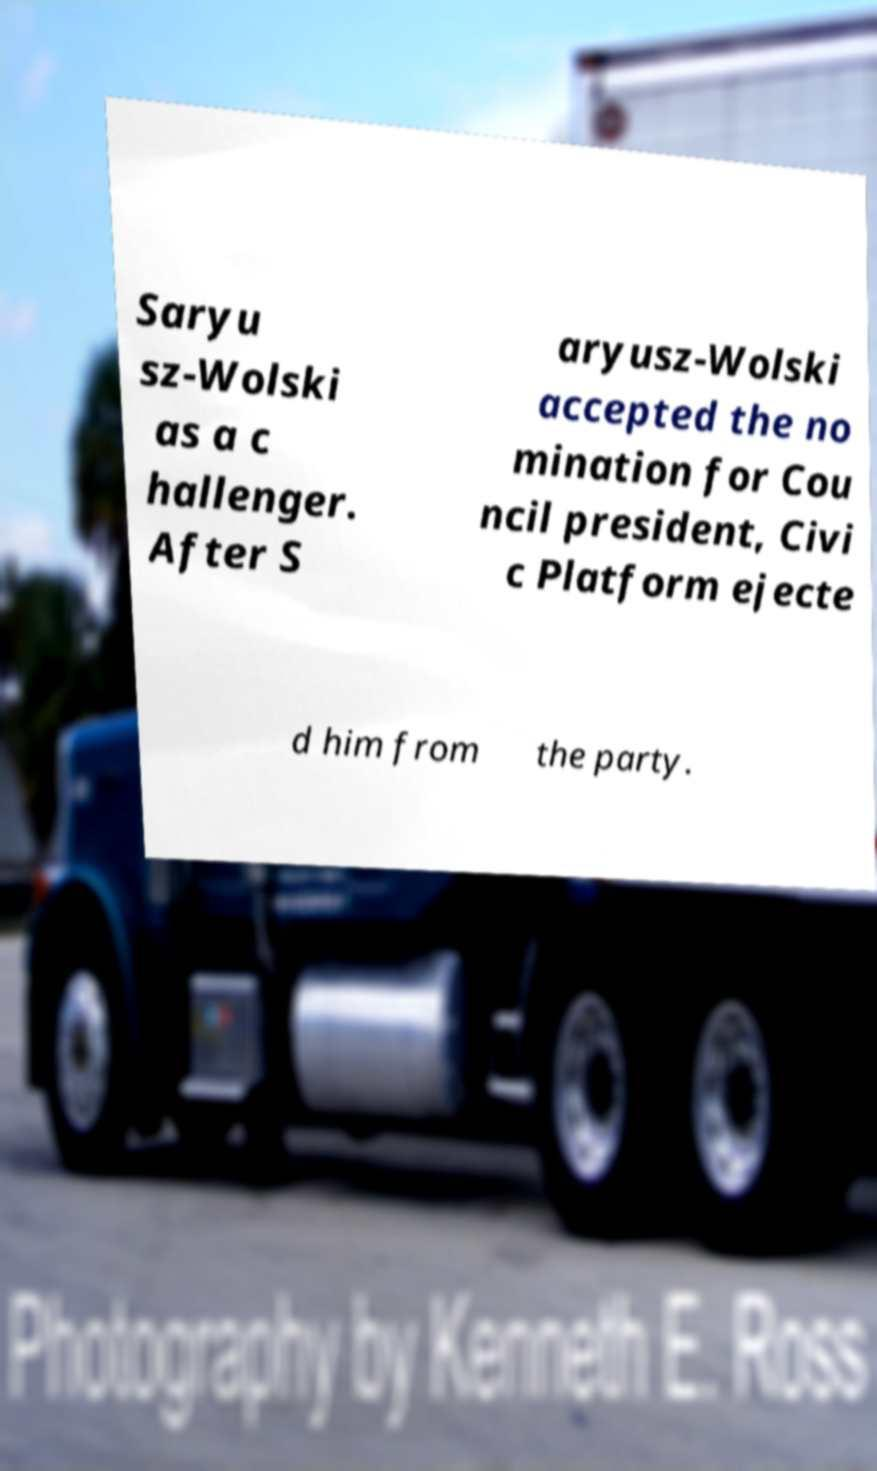What messages or text are displayed in this image? I need them in a readable, typed format. Saryu sz-Wolski as a c hallenger. After S aryusz-Wolski accepted the no mination for Cou ncil president, Civi c Platform ejecte d him from the party. 